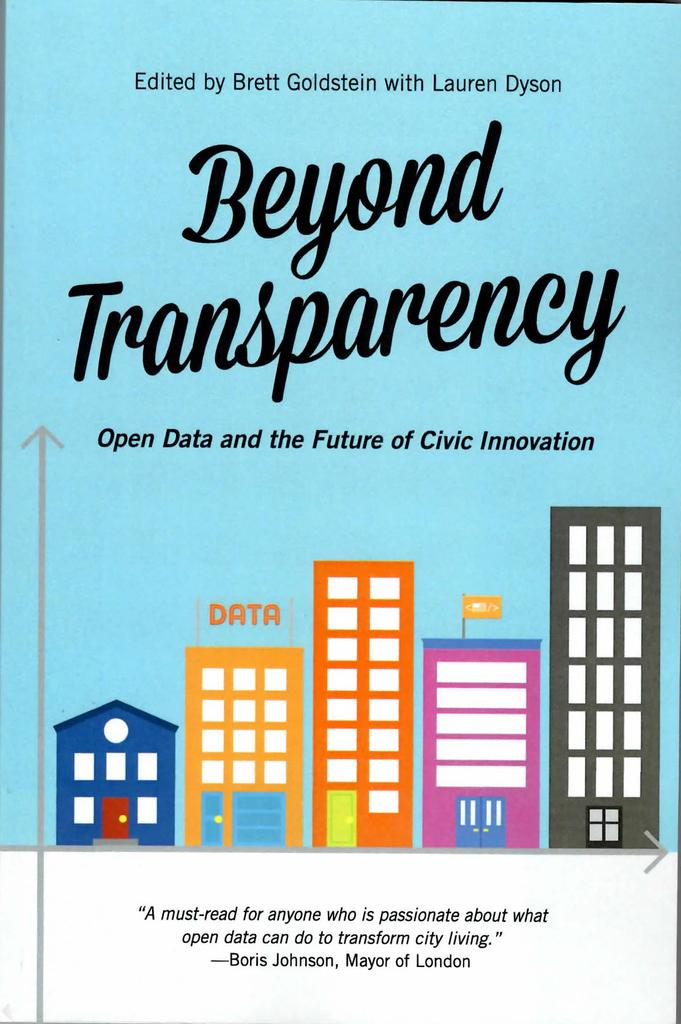What type of visual is the image in question? The image is a poster. What can be found on the poster besides images? There is text on the poster. What type of structures are depicted on the poster? There are images of buildings on the poster. Is there any symbol of a country or organization on the poster? Yes, there is an image of a flag on the poster. What type of lumber is used to create the buildings depicted on the poster? There is no information about the type of lumber used to create the buildings in the image. 